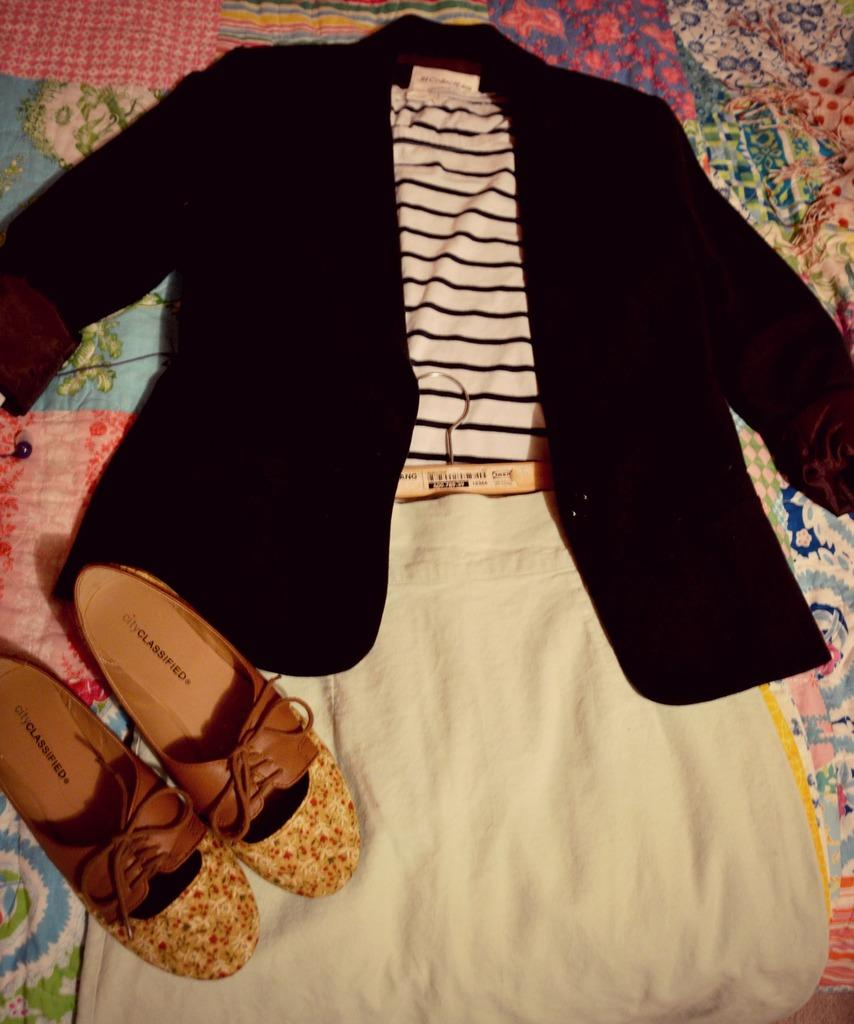<image>
Present a compact description of the photo's key features. A pair of shoes from City Classified sit next to an outfit that includes a striped shirt. 